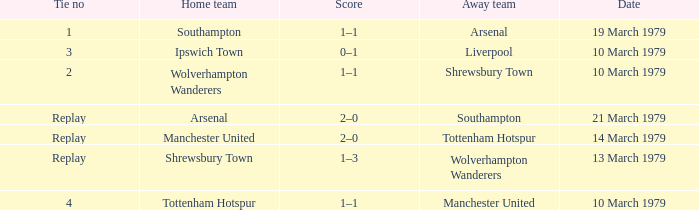What was the score of the tie that had Tottenham Hotspur as the home team? 1–1. 